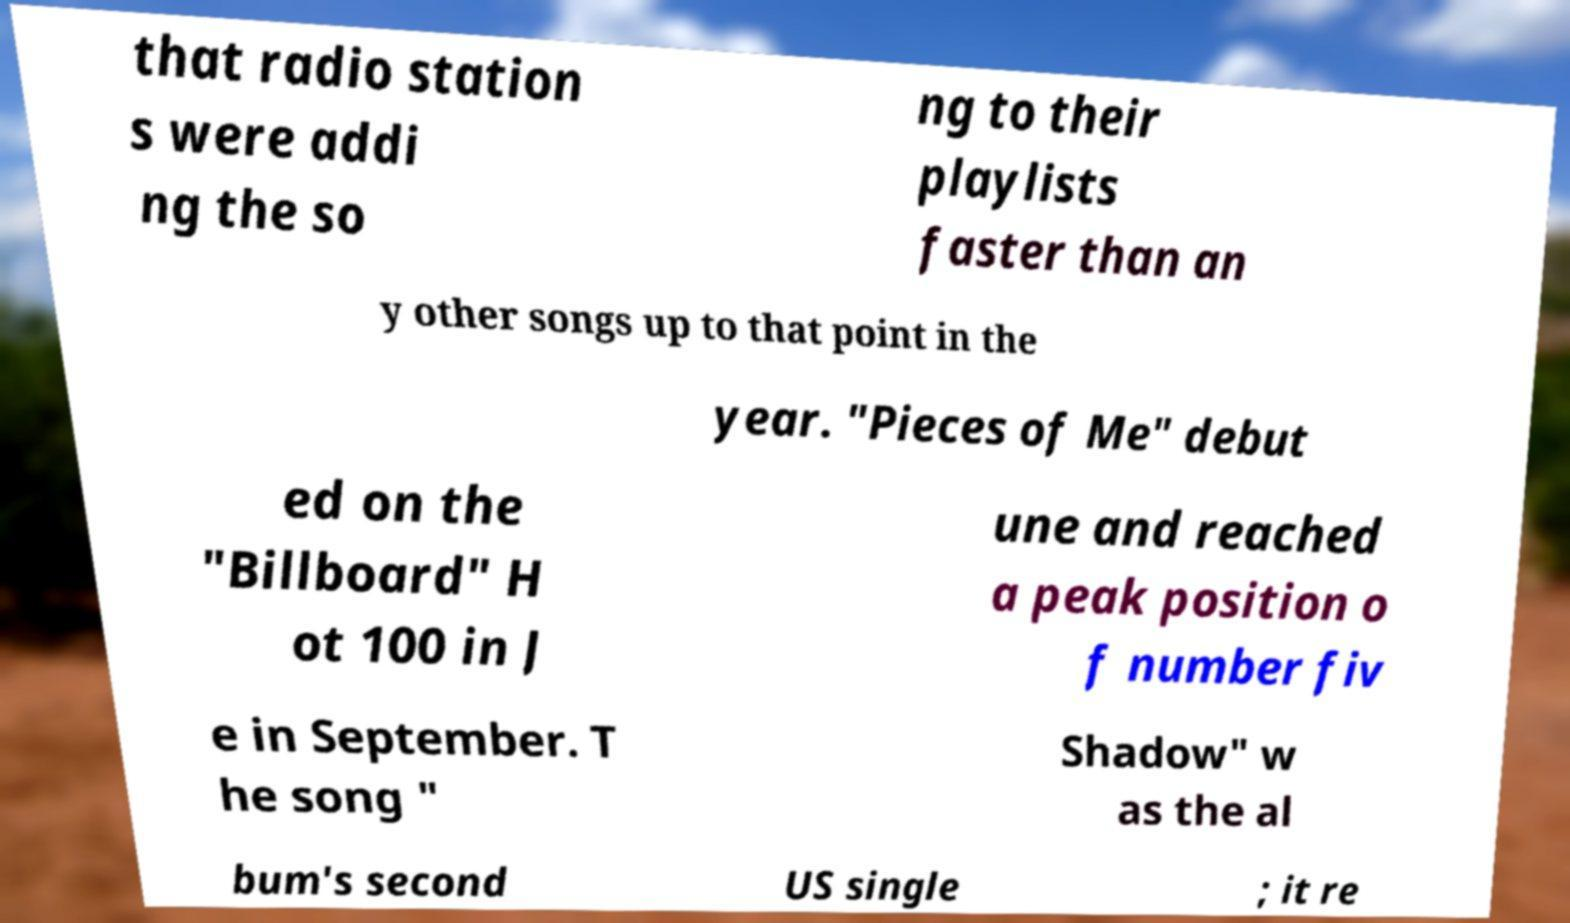For documentation purposes, I need the text within this image transcribed. Could you provide that? that radio station s were addi ng the so ng to their playlists faster than an y other songs up to that point in the year. "Pieces of Me" debut ed on the "Billboard" H ot 100 in J une and reached a peak position o f number fiv e in September. T he song " Shadow" w as the al bum's second US single ; it re 